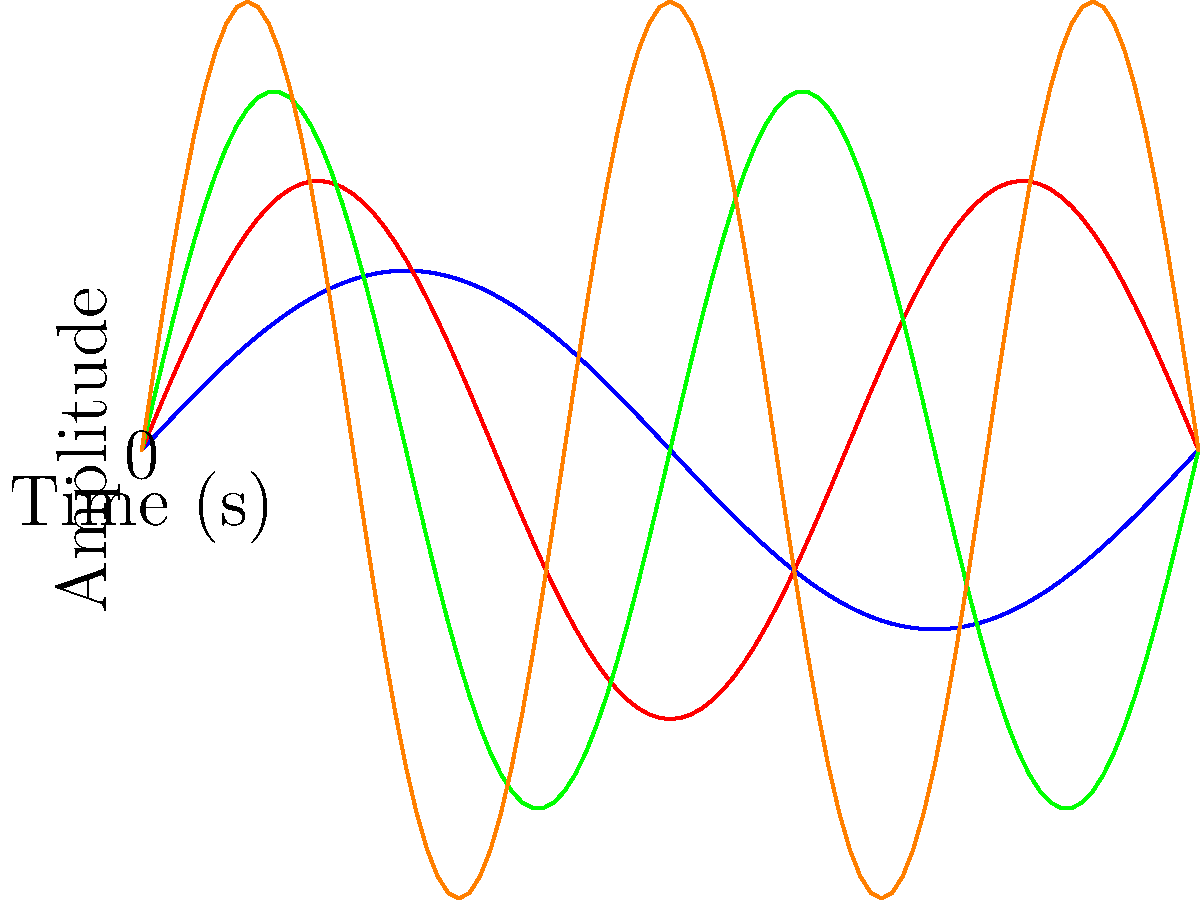The graph shows sound waves produced by four different cello string vibrations (A, B, C, and D). Which string produces the highest frequency? To determine which string produces the highest frequency, we need to analyze the number of complete cycles each wave completes within the given time frame. The frequency of a wave is directly proportional to the number of cycles it completes in a given time.

Let's examine each wave:

1. Wave A (blue): Completes 1 full cycle in the given time frame.
2. Wave B (red): Completes 1.5 cycles.
3. Wave C (green): Completes 2 full cycles.
4. Wave D (orange): Completes 2.5 cycles.

The wave that completes the most cycles in the given time frame has the highest frequency. In this case, it's Wave D (orange), which completes 2.5 cycles.

In terms of cello strings, higher frequencies correspond to higher pitches. Therefore, the string producing Wave D would be the highest-pitched string on the cello, which is typically the A string.
Answer: D 